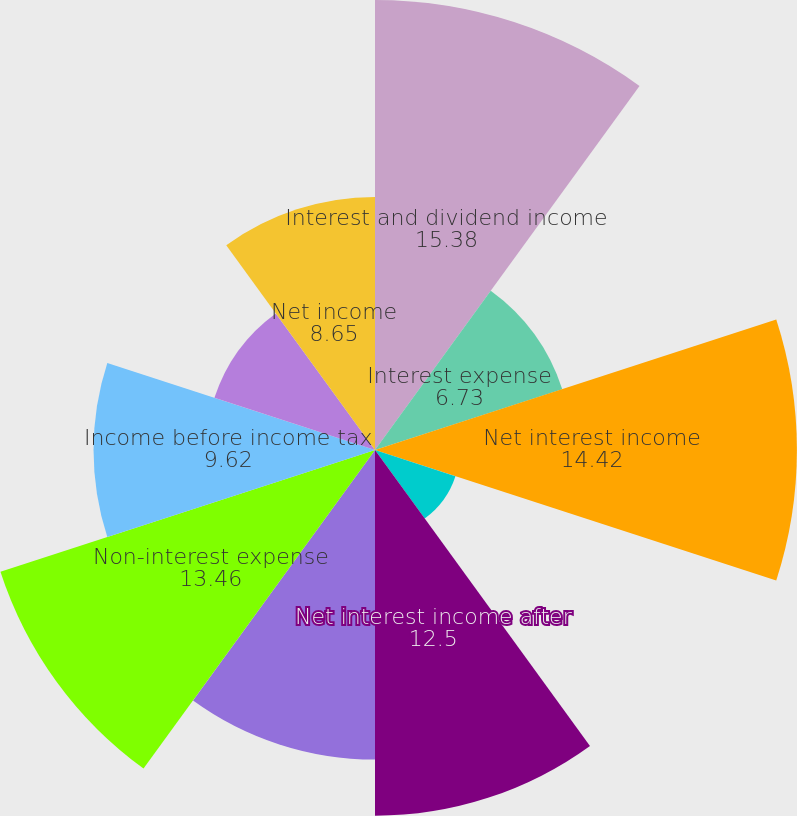Convert chart to OTSL. <chart><loc_0><loc_0><loc_500><loc_500><pie_chart><fcel>Interest and dividend income<fcel>Interest expense<fcel>Net interest income<fcel>Provision for loan losses<fcel>Net interest income after<fcel>Non-interest income<fcel>Non-interest expense<fcel>Income before income tax<fcel>Income tax expense<fcel>Net income<nl><fcel>15.38%<fcel>6.73%<fcel>14.42%<fcel>2.89%<fcel>12.5%<fcel>10.58%<fcel>13.46%<fcel>9.62%<fcel>5.77%<fcel>8.65%<nl></chart> 